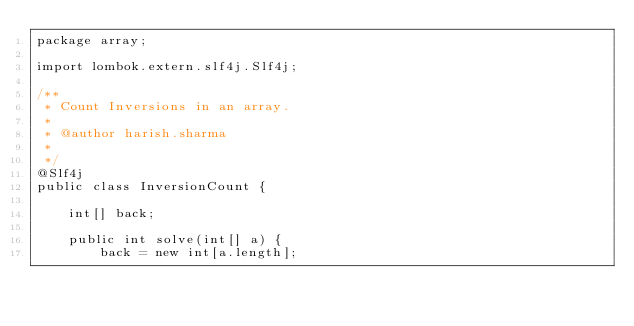Convert code to text. <code><loc_0><loc_0><loc_500><loc_500><_Java_>package array;

import lombok.extern.slf4j.Slf4j;

/**
 * Count Inversions in an array.
 * 
 * @author harish.sharma
 *
 */
@Slf4j
public class InversionCount {

    int[] back;

    public int solve(int[] a) {
        back = new int[a.length];</code> 